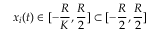<formula> <loc_0><loc_0><loc_500><loc_500>x _ { i } ( t ) \in [ - \frac { R } { K } , \frac { R } { 2 } ] \subset [ - \frac { R } { 2 } , \frac { R } { 2 } ]</formula> 